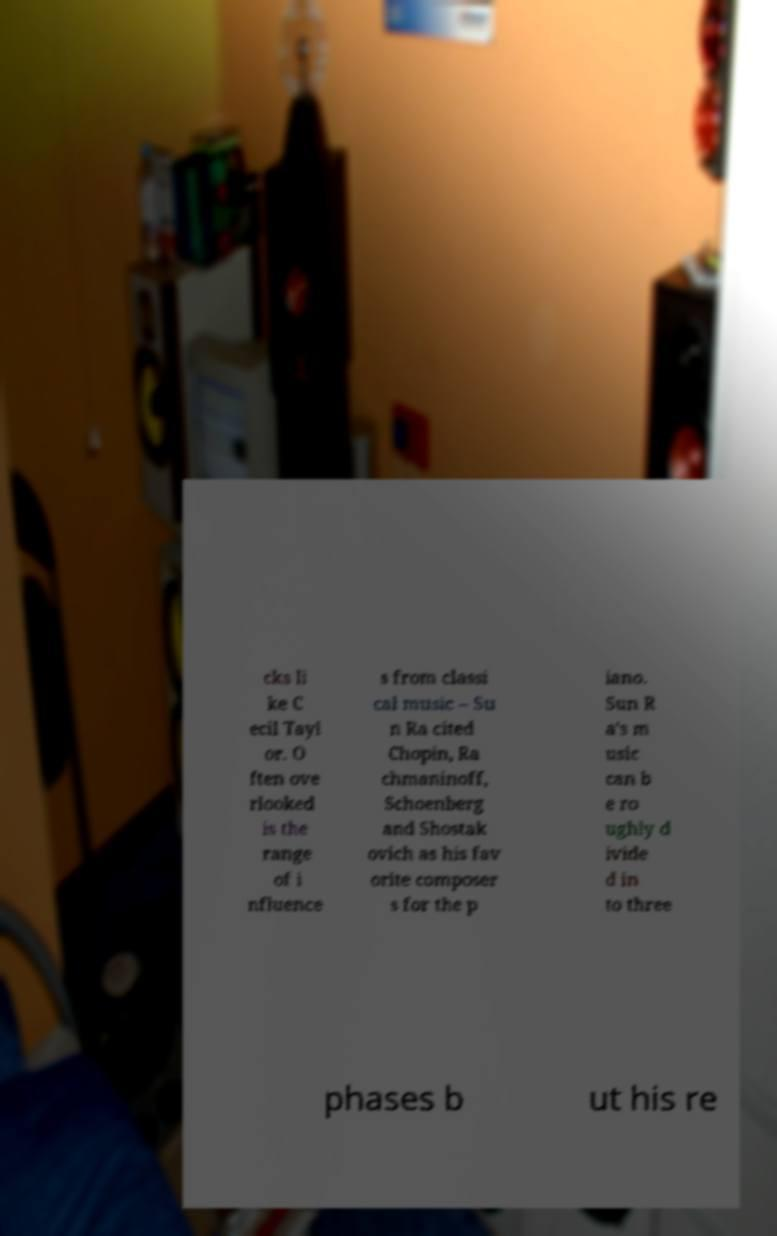Please read and relay the text visible in this image. What does it say? cks li ke C ecil Tayl or. O ften ove rlooked is the range of i nfluence s from classi cal music – Su n Ra cited Chopin, Ra chmaninoff, Schoenberg and Shostak ovich as his fav orite composer s for the p iano. Sun R a's m usic can b e ro ughly d ivide d in to three phases b ut his re 